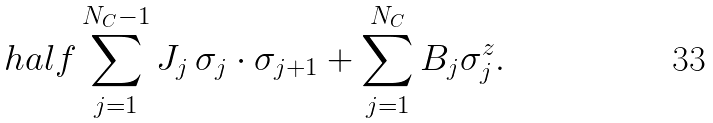Convert formula to latex. <formula><loc_0><loc_0><loc_500><loc_500>\ h a l f \sum _ { j = 1 } ^ { N _ { C } - 1 } J _ { j } \, \sigma _ { j } \cdot \sigma _ { j + 1 } + \sum _ { j = 1 } ^ { N _ { C } } B _ { j } \sigma ^ { z } _ { j } .</formula> 